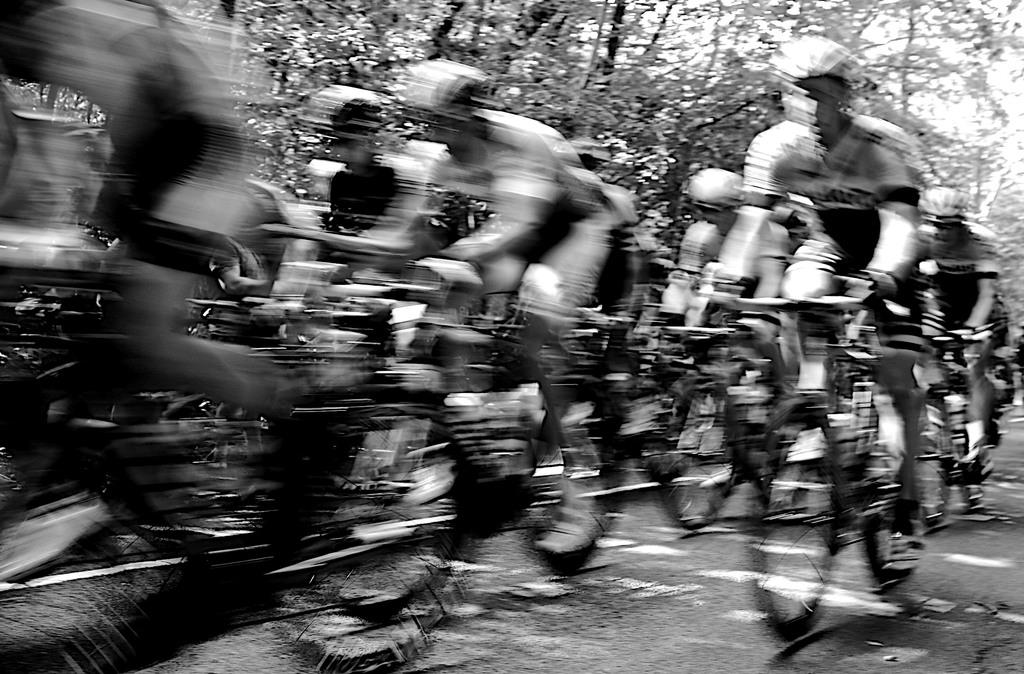What is the color scheme of the image? The image is black and white. What are the people in the image doing? The people are riding bicycles in the image. What can be seen on the left side of the image? There is a blurred view on the left side of the image. What is visible in the background of the image? There are trees in the background of the image. What type of wine is being served to the queen in the image? There is no queen or wine present in the image; it features people riding bicycles with a blurred view and trees in the background. 